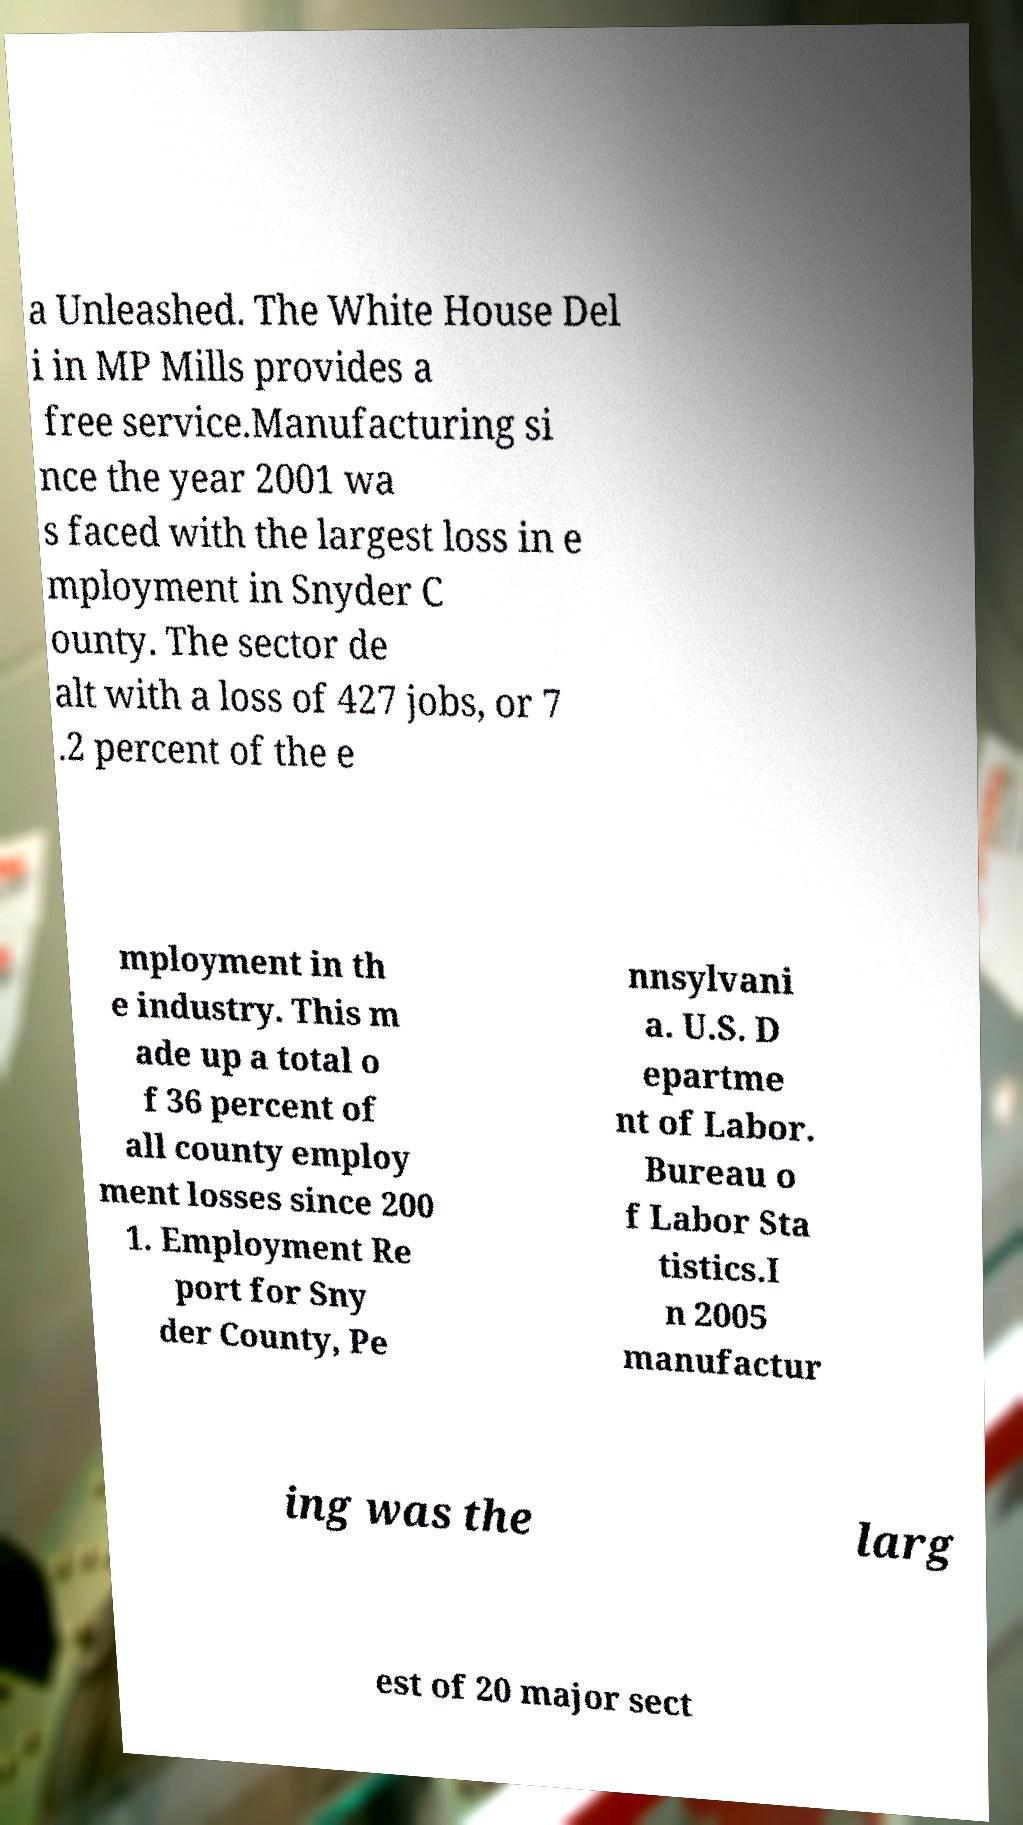Could you extract and type out the text from this image? a Unleashed. The White House Del i in MP Mills provides a free service.Manufacturing si nce the year 2001 wa s faced with the largest loss in e mployment in Snyder C ounty. The sector de alt with a loss of 427 jobs, or 7 .2 percent of the e mployment in th e industry. This m ade up a total o f 36 percent of all county employ ment losses since 200 1. Employment Re port for Sny der County, Pe nnsylvani a. U.S. D epartme nt of Labor. Bureau o f Labor Sta tistics.I n 2005 manufactur ing was the larg est of 20 major sect 